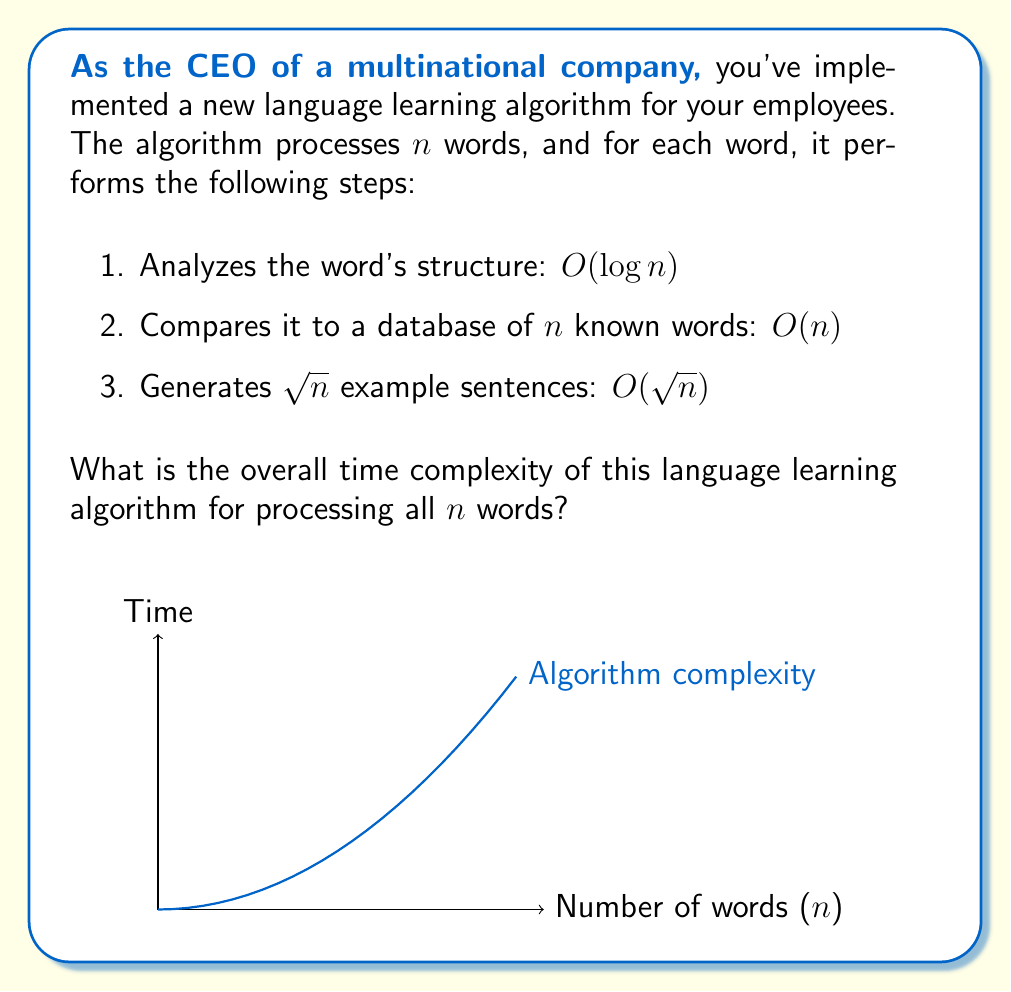Give your solution to this math problem. Let's analyze the time complexity step by step:

1. For each word:
   a. Word structure analysis: $O(\log n)$
   b. Database comparison: $O(n)$
   c. Example sentence generation: $O(\sqrt{n})$

2. The total complexity for processing one word is:
   $O(\log n + n + \sqrt{n})$

3. Since $n > \sqrt{n} > \log n$ for large values of $n$, we can simplify this to:
   $O(n)$ for each word

4. We perform these operations for all $n$ words, so we multiply by $n$:
   $O(n) * n = O(n^2)$

Therefore, the overall time complexity for processing all $n$ words is $O(n^2)$.

This quadratic time complexity indicates that the algorithm's running time grows quadratically with the input size, which may become inefficient for very large datasets of words.
Answer: $O(n^2)$ 